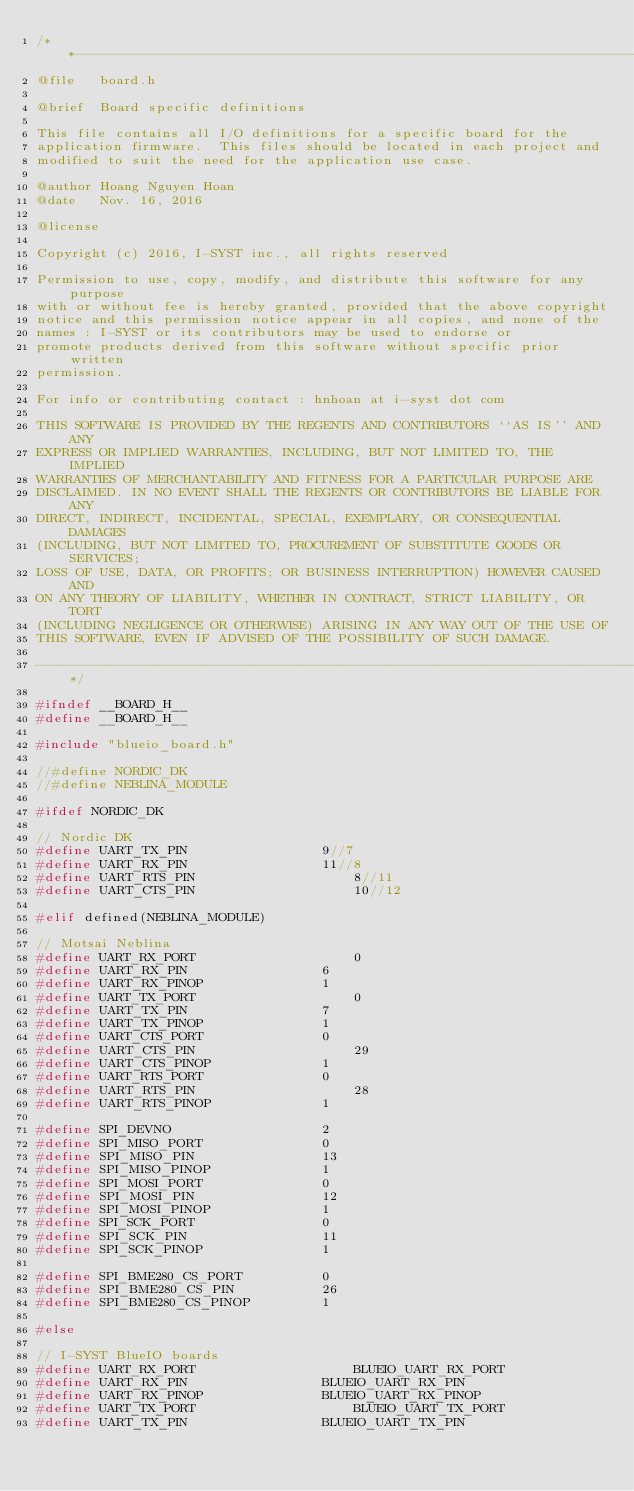<code> <loc_0><loc_0><loc_500><loc_500><_C_>/**-------------------------------------------------------------------------
@file	board.h

@brief	Board specific definitions

This file contains all I/O definitions for a specific board for the
application firmware.  This files should be located in each project and
modified to suit the need for the application use case.

@author	Hoang Nguyen Hoan
@date	Nov. 16, 2016

@license

Copyright (c) 2016, I-SYST inc., all rights reserved

Permission to use, copy, modify, and distribute this software for any purpose
with or without fee is hereby granted, provided that the above copyright
notice and this permission notice appear in all copies, and none of the
names : I-SYST or its contributors may be used to endorse or
promote products derived from this software without specific prior written
permission.

For info or contributing contact : hnhoan at i-syst dot com

THIS SOFTWARE IS PROVIDED BY THE REGENTS AND CONTRIBUTORS ``AS IS'' AND ANY
EXPRESS OR IMPLIED WARRANTIES, INCLUDING, BUT NOT LIMITED TO, THE IMPLIED
WARRANTIES OF MERCHANTABILITY AND FITNESS FOR A PARTICULAR PURPOSE ARE
DISCLAIMED. IN NO EVENT SHALL THE REGENTS OR CONTRIBUTORS BE LIABLE FOR ANY
DIRECT, INDIRECT, INCIDENTAL, SPECIAL, EXEMPLARY, OR CONSEQUENTIAL DAMAGES
(INCLUDING, BUT NOT LIMITED TO, PROCUREMENT OF SUBSTITUTE GOODS OR SERVICES;
LOSS OF USE, DATA, OR PROFITS; OR BUSINESS INTERRUPTION) HOWEVER CAUSED AND
ON ANY THEORY OF LIABILITY, WHETHER IN CONTRACT, STRICT LIABILITY, OR TORT
(INCLUDING NEGLIGENCE OR OTHERWISE) ARISING IN ANY WAY OUT OF THE USE OF
THIS SOFTWARE, EVEN IF ADVISED OF THE POSSIBILITY OF SUCH DAMAGE.

----------------------------------------------------------------------------*/

#ifndef __BOARD_H__
#define __BOARD_H__

#include "blueio_board.h"

//#define NORDIC_DK
//#define NEBLINA_MODULE

#ifdef NORDIC_DK

// Nordic DK
#define UART_TX_PIN					9//7
#define UART_RX_PIN					11//8
#define UART_RTS_PIN					8//11
#define UART_CTS_PIN					10//12

#elif defined(NEBLINA_MODULE)

// Motsai Neblina
#define UART_RX_PORT					0
#define UART_RX_PIN					6
#define UART_RX_PINOP				1
#define UART_TX_PORT					0
#define UART_TX_PIN					7
#define UART_TX_PINOP				1
#define UART_CTS_PORT				0
#define UART_CTS_PIN					29
#define UART_CTS_PINOP				1
#define UART_RTS_PORT				0
#define UART_RTS_PIN					28
#define UART_RTS_PINOP				1

#define SPI_DEVNO            		2
#define SPI_MISO_PORT        		0
#define SPI_MISO_PIN         		13
#define SPI_MISO_PINOP       		1
#define SPI_MOSI_PORT        		0
#define SPI_MOSI_PIN         		12
#define SPI_MOSI_PINOP       		1
#define SPI_SCK_PORT         		0
#define SPI_SCK_PIN          		11
#define SPI_SCK_PINOP        		1

#define SPI_BME280_CS_PORT         	0
#define SPI_BME280_CS_PIN          	26
#define SPI_BME280_CS_PINOP        	1

#else

// I-SYST BlueIO boards
#define UART_RX_PORT					BLUEIO_UART_RX_PORT
#define UART_RX_PIN					BLUEIO_UART_RX_PIN
#define UART_RX_PINOP				BLUEIO_UART_RX_PINOP
#define UART_TX_PORT					BLUEIO_UART_TX_PORT
#define UART_TX_PIN					BLUEIO_UART_TX_PIN</code> 